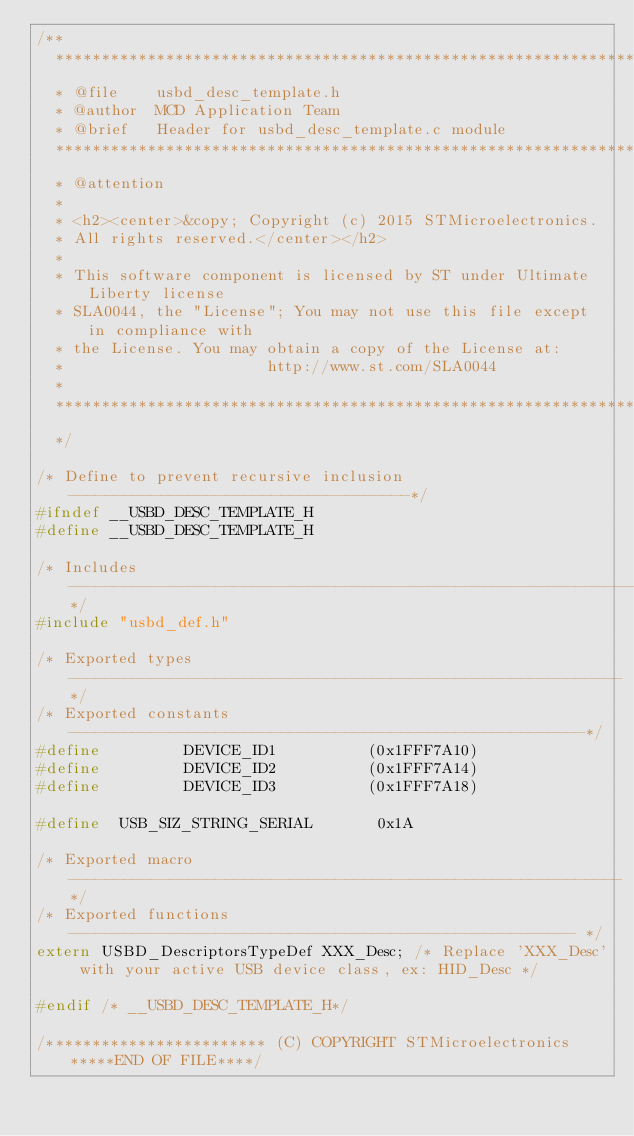Convert code to text. <code><loc_0><loc_0><loc_500><loc_500><_C_>/**
  ******************************************************************************
  * @file    usbd_desc_template.h
  * @author  MCD Application Team
  * @brief   Header for usbd_desc_template.c module
  ******************************************************************************
  * @attention
  *
  * <h2><center>&copy; Copyright (c) 2015 STMicroelectronics.
  * All rights reserved.</center></h2>
  *
  * This software component is licensed by ST under Ultimate Liberty license
  * SLA0044, the "License"; You may not use this file except in compliance with
  * the License. You may obtain a copy of the License at:
  *                      http://www.st.com/SLA0044
  *
  ******************************************************************************
  */

/* Define to prevent recursive inclusion -------------------------------------*/
#ifndef __USBD_DESC_TEMPLATE_H
#define __USBD_DESC_TEMPLATE_H

/* Includes ------------------------------------------------------------------*/
#include "usbd_def.h"

/* Exported types ------------------------------------------------------------*/
/* Exported constants --------------------------------------------------------*/
#define         DEVICE_ID1          (0x1FFF7A10)
#define         DEVICE_ID2          (0x1FFF7A14)
#define         DEVICE_ID3          (0x1FFF7A18)

#define  USB_SIZ_STRING_SERIAL       0x1A

/* Exported macro ------------------------------------------------------------*/
/* Exported functions ------------------------------------------------------- */
extern USBD_DescriptorsTypeDef XXX_Desc; /* Replace 'XXX_Desc' with your active USB device class, ex: HID_Desc */

#endif /* __USBD_DESC_TEMPLATE_H*/

/************************ (C) COPYRIGHT STMicroelectronics *****END OF FILE****/
</code> 